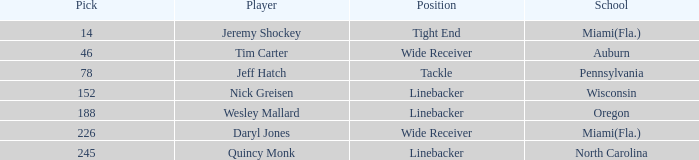Would you be able to parse every entry in this table? {'header': ['Pick', 'Player', 'Position', 'School'], 'rows': [['14', 'Jeremy Shockey', 'Tight End', 'Miami(Fla.)'], ['46', 'Tim Carter', 'Wide Receiver', 'Auburn'], ['78', 'Jeff Hatch', 'Tackle', 'Pennsylvania'], ['152', 'Nick Greisen', 'Linebacker', 'Wisconsin'], ['188', 'Wesley Mallard', 'Linebacker', 'Oregon'], ['226', 'Daryl Jones', 'Wide Receiver', 'Miami(Fla.)'], ['245', 'Quincy Monk', 'Linebacker', 'North Carolina']]} From what school was the player drafted in round 3? Pennsylvania. 